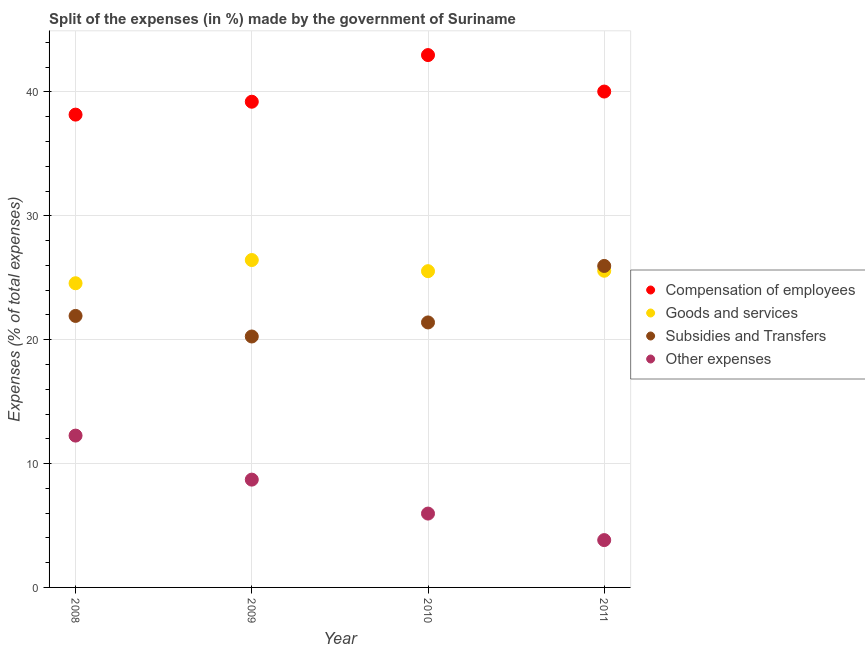How many different coloured dotlines are there?
Ensure brevity in your answer.  4. What is the percentage of amount spent on other expenses in 2011?
Offer a terse response. 3.82. Across all years, what is the maximum percentage of amount spent on subsidies?
Offer a very short reply. 25.95. Across all years, what is the minimum percentage of amount spent on subsidies?
Provide a succinct answer. 20.26. In which year was the percentage of amount spent on other expenses maximum?
Your answer should be very brief. 2008. In which year was the percentage of amount spent on compensation of employees minimum?
Your response must be concise. 2008. What is the total percentage of amount spent on goods and services in the graph?
Keep it short and to the point. 102.08. What is the difference between the percentage of amount spent on goods and services in 2008 and that in 2011?
Provide a succinct answer. -1.01. What is the difference between the percentage of amount spent on goods and services in 2011 and the percentage of amount spent on compensation of employees in 2008?
Provide a short and direct response. -12.6. What is the average percentage of amount spent on goods and services per year?
Offer a terse response. 25.52. In the year 2009, what is the difference between the percentage of amount spent on other expenses and percentage of amount spent on goods and services?
Give a very brief answer. -17.73. In how many years, is the percentage of amount spent on other expenses greater than 18 %?
Your answer should be compact. 0. What is the ratio of the percentage of amount spent on goods and services in 2009 to that in 2011?
Provide a short and direct response. 1.03. Is the percentage of amount spent on other expenses in 2009 less than that in 2010?
Ensure brevity in your answer.  No. Is the difference between the percentage of amount spent on other expenses in 2009 and 2010 greater than the difference between the percentage of amount spent on goods and services in 2009 and 2010?
Give a very brief answer. Yes. What is the difference between the highest and the second highest percentage of amount spent on compensation of employees?
Keep it short and to the point. 2.94. What is the difference between the highest and the lowest percentage of amount spent on goods and services?
Your response must be concise. 1.87. In how many years, is the percentage of amount spent on goods and services greater than the average percentage of amount spent on goods and services taken over all years?
Make the answer very short. 3. Is it the case that in every year, the sum of the percentage of amount spent on subsidies and percentage of amount spent on compensation of employees is greater than the sum of percentage of amount spent on other expenses and percentage of amount spent on goods and services?
Your response must be concise. Yes. Is it the case that in every year, the sum of the percentage of amount spent on compensation of employees and percentage of amount spent on goods and services is greater than the percentage of amount spent on subsidies?
Your answer should be very brief. Yes. Is the percentage of amount spent on subsidies strictly greater than the percentage of amount spent on other expenses over the years?
Make the answer very short. Yes. How many years are there in the graph?
Make the answer very short. 4. What is the difference between two consecutive major ticks on the Y-axis?
Keep it short and to the point. 10. Are the values on the major ticks of Y-axis written in scientific E-notation?
Ensure brevity in your answer.  No. Does the graph contain any zero values?
Provide a succinct answer. No. Does the graph contain grids?
Your answer should be very brief. Yes. How many legend labels are there?
Give a very brief answer. 4. What is the title of the graph?
Offer a terse response. Split of the expenses (in %) made by the government of Suriname. What is the label or title of the Y-axis?
Your answer should be compact. Expenses (% of total expenses). What is the Expenses (% of total expenses) of Compensation of employees in 2008?
Provide a succinct answer. 38.17. What is the Expenses (% of total expenses) in Goods and services in 2008?
Provide a succinct answer. 24.56. What is the Expenses (% of total expenses) of Subsidies and Transfers in 2008?
Provide a short and direct response. 21.92. What is the Expenses (% of total expenses) in Other expenses in 2008?
Your response must be concise. 12.26. What is the Expenses (% of total expenses) of Compensation of employees in 2009?
Offer a very short reply. 39.21. What is the Expenses (% of total expenses) of Goods and services in 2009?
Offer a very short reply. 26.43. What is the Expenses (% of total expenses) of Subsidies and Transfers in 2009?
Your answer should be compact. 20.26. What is the Expenses (% of total expenses) in Other expenses in 2009?
Provide a succinct answer. 8.7. What is the Expenses (% of total expenses) in Compensation of employees in 2010?
Your answer should be very brief. 42.98. What is the Expenses (% of total expenses) in Goods and services in 2010?
Offer a terse response. 25.53. What is the Expenses (% of total expenses) of Subsidies and Transfers in 2010?
Offer a very short reply. 21.39. What is the Expenses (% of total expenses) of Other expenses in 2010?
Keep it short and to the point. 5.96. What is the Expenses (% of total expenses) in Compensation of employees in 2011?
Keep it short and to the point. 40.03. What is the Expenses (% of total expenses) in Goods and services in 2011?
Keep it short and to the point. 25.57. What is the Expenses (% of total expenses) in Subsidies and Transfers in 2011?
Offer a terse response. 25.95. What is the Expenses (% of total expenses) in Other expenses in 2011?
Provide a short and direct response. 3.82. Across all years, what is the maximum Expenses (% of total expenses) in Compensation of employees?
Make the answer very short. 42.98. Across all years, what is the maximum Expenses (% of total expenses) in Goods and services?
Provide a succinct answer. 26.43. Across all years, what is the maximum Expenses (% of total expenses) of Subsidies and Transfers?
Make the answer very short. 25.95. Across all years, what is the maximum Expenses (% of total expenses) in Other expenses?
Your answer should be compact. 12.26. Across all years, what is the minimum Expenses (% of total expenses) in Compensation of employees?
Provide a short and direct response. 38.17. Across all years, what is the minimum Expenses (% of total expenses) of Goods and services?
Your answer should be compact. 24.56. Across all years, what is the minimum Expenses (% of total expenses) of Subsidies and Transfers?
Your answer should be compact. 20.26. Across all years, what is the minimum Expenses (% of total expenses) in Other expenses?
Provide a succinct answer. 3.82. What is the total Expenses (% of total expenses) of Compensation of employees in the graph?
Give a very brief answer. 160.38. What is the total Expenses (% of total expenses) of Goods and services in the graph?
Make the answer very short. 102.08. What is the total Expenses (% of total expenses) in Subsidies and Transfers in the graph?
Keep it short and to the point. 89.52. What is the total Expenses (% of total expenses) in Other expenses in the graph?
Keep it short and to the point. 30.74. What is the difference between the Expenses (% of total expenses) in Compensation of employees in 2008 and that in 2009?
Your response must be concise. -1.04. What is the difference between the Expenses (% of total expenses) of Goods and services in 2008 and that in 2009?
Provide a short and direct response. -1.87. What is the difference between the Expenses (% of total expenses) in Subsidies and Transfers in 2008 and that in 2009?
Provide a short and direct response. 1.66. What is the difference between the Expenses (% of total expenses) of Other expenses in 2008 and that in 2009?
Offer a terse response. 3.55. What is the difference between the Expenses (% of total expenses) in Compensation of employees in 2008 and that in 2010?
Your answer should be very brief. -4.81. What is the difference between the Expenses (% of total expenses) of Goods and services in 2008 and that in 2010?
Provide a succinct answer. -0.97. What is the difference between the Expenses (% of total expenses) of Subsidies and Transfers in 2008 and that in 2010?
Provide a short and direct response. 0.53. What is the difference between the Expenses (% of total expenses) in Other expenses in 2008 and that in 2010?
Your answer should be compact. 6.29. What is the difference between the Expenses (% of total expenses) of Compensation of employees in 2008 and that in 2011?
Your answer should be very brief. -1.86. What is the difference between the Expenses (% of total expenses) in Goods and services in 2008 and that in 2011?
Make the answer very short. -1.01. What is the difference between the Expenses (% of total expenses) of Subsidies and Transfers in 2008 and that in 2011?
Your answer should be very brief. -4.03. What is the difference between the Expenses (% of total expenses) in Other expenses in 2008 and that in 2011?
Offer a very short reply. 8.44. What is the difference between the Expenses (% of total expenses) of Compensation of employees in 2009 and that in 2010?
Offer a very short reply. -3.77. What is the difference between the Expenses (% of total expenses) of Goods and services in 2009 and that in 2010?
Your answer should be very brief. 0.9. What is the difference between the Expenses (% of total expenses) of Subsidies and Transfers in 2009 and that in 2010?
Your answer should be very brief. -1.13. What is the difference between the Expenses (% of total expenses) of Other expenses in 2009 and that in 2010?
Provide a succinct answer. 2.74. What is the difference between the Expenses (% of total expenses) of Compensation of employees in 2009 and that in 2011?
Offer a very short reply. -0.82. What is the difference between the Expenses (% of total expenses) in Goods and services in 2009 and that in 2011?
Provide a short and direct response. 0.86. What is the difference between the Expenses (% of total expenses) in Subsidies and Transfers in 2009 and that in 2011?
Give a very brief answer. -5.69. What is the difference between the Expenses (% of total expenses) in Other expenses in 2009 and that in 2011?
Offer a very short reply. 4.88. What is the difference between the Expenses (% of total expenses) in Compensation of employees in 2010 and that in 2011?
Offer a terse response. 2.94. What is the difference between the Expenses (% of total expenses) of Goods and services in 2010 and that in 2011?
Your answer should be compact. -0.03. What is the difference between the Expenses (% of total expenses) in Subsidies and Transfers in 2010 and that in 2011?
Give a very brief answer. -4.56. What is the difference between the Expenses (% of total expenses) in Other expenses in 2010 and that in 2011?
Keep it short and to the point. 2.14. What is the difference between the Expenses (% of total expenses) in Compensation of employees in 2008 and the Expenses (% of total expenses) in Goods and services in 2009?
Make the answer very short. 11.74. What is the difference between the Expenses (% of total expenses) of Compensation of employees in 2008 and the Expenses (% of total expenses) of Subsidies and Transfers in 2009?
Ensure brevity in your answer.  17.91. What is the difference between the Expenses (% of total expenses) of Compensation of employees in 2008 and the Expenses (% of total expenses) of Other expenses in 2009?
Keep it short and to the point. 29.47. What is the difference between the Expenses (% of total expenses) of Goods and services in 2008 and the Expenses (% of total expenses) of Subsidies and Transfers in 2009?
Your answer should be very brief. 4.3. What is the difference between the Expenses (% of total expenses) in Goods and services in 2008 and the Expenses (% of total expenses) in Other expenses in 2009?
Offer a terse response. 15.85. What is the difference between the Expenses (% of total expenses) in Subsidies and Transfers in 2008 and the Expenses (% of total expenses) in Other expenses in 2009?
Provide a succinct answer. 13.22. What is the difference between the Expenses (% of total expenses) of Compensation of employees in 2008 and the Expenses (% of total expenses) of Goods and services in 2010?
Make the answer very short. 12.64. What is the difference between the Expenses (% of total expenses) in Compensation of employees in 2008 and the Expenses (% of total expenses) in Subsidies and Transfers in 2010?
Make the answer very short. 16.78. What is the difference between the Expenses (% of total expenses) of Compensation of employees in 2008 and the Expenses (% of total expenses) of Other expenses in 2010?
Make the answer very short. 32.21. What is the difference between the Expenses (% of total expenses) of Goods and services in 2008 and the Expenses (% of total expenses) of Subsidies and Transfers in 2010?
Give a very brief answer. 3.16. What is the difference between the Expenses (% of total expenses) of Goods and services in 2008 and the Expenses (% of total expenses) of Other expenses in 2010?
Ensure brevity in your answer.  18.59. What is the difference between the Expenses (% of total expenses) of Subsidies and Transfers in 2008 and the Expenses (% of total expenses) of Other expenses in 2010?
Your response must be concise. 15.96. What is the difference between the Expenses (% of total expenses) of Compensation of employees in 2008 and the Expenses (% of total expenses) of Goods and services in 2011?
Keep it short and to the point. 12.6. What is the difference between the Expenses (% of total expenses) in Compensation of employees in 2008 and the Expenses (% of total expenses) in Subsidies and Transfers in 2011?
Give a very brief answer. 12.22. What is the difference between the Expenses (% of total expenses) of Compensation of employees in 2008 and the Expenses (% of total expenses) of Other expenses in 2011?
Ensure brevity in your answer.  34.35. What is the difference between the Expenses (% of total expenses) in Goods and services in 2008 and the Expenses (% of total expenses) in Subsidies and Transfers in 2011?
Provide a succinct answer. -1.4. What is the difference between the Expenses (% of total expenses) in Goods and services in 2008 and the Expenses (% of total expenses) in Other expenses in 2011?
Provide a succinct answer. 20.73. What is the difference between the Expenses (% of total expenses) of Subsidies and Transfers in 2008 and the Expenses (% of total expenses) of Other expenses in 2011?
Give a very brief answer. 18.1. What is the difference between the Expenses (% of total expenses) of Compensation of employees in 2009 and the Expenses (% of total expenses) of Goods and services in 2010?
Offer a very short reply. 13.68. What is the difference between the Expenses (% of total expenses) of Compensation of employees in 2009 and the Expenses (% of total expenses) of Subsidies and Transfers in 2010?
Offer a very short reply. 17.82. What is the difference between the Expenses (% of total expenses) in Compensation of employees in 2009 and the Expenses (% of total expenses) in Other expenses in 2010?
Your answer should be compact. 33.25. What is the difference between the Expenses (% of total expenses) in Goods and services in 2009 and the Expenses (% of total expenses) in Subsidies and Transfers in 2010?
Keep it short and to the point. 5.04. What is the difference between the Expenses (% of total expenses) in Goods and services in 2009 and the Expenses (% of total expenses) in Other expenses in 2010?
Your answer should be compact. 20.47. What is the difference between the Expenses (% of total expenses) in Subsidies and Transfers in 2009 and the Expenses (% of total expenses) in Other expenses in 2010?
Your answer should be very brief. 14.3. What is the difference between the Expenses (% of total expenses) of Compensation of employees in 2009 and the Expenses (% of total expenses) of Goods and services in 2011?
Offer a very short reply. 13.64. What is the difference between the Expenses (% of total expenses) in Compensation of employees in 2009 and the Expenses (% of total expenses) in Subsidies and Transfers in 2011?
Offer a terse response. 13.26. What is the difference between the Expenses (% of total expenses) in Compensation of employees in 2009 and the Expenses (% of total expenses) in Other expenses in 2011?
Provide a succinct answer. 35.39. What is the difference between the Expenses (% of total expenses) of Goods and services in 2009 and the Expenses (% of total expenses) of Subsidies and Transfers in 2011?
Your answer should be compact. 0.48. What is the difference between the Expenses (% of total expenses) in Goods and services in 2009 and the Expenses (% of total expenses) in Other expenses in 2011?
Provide a succinct answer. 22.61. What is the difference between the Expenses (% of total expenses) in Subsidies and Transfers in 2009 and the Expenses (% of total expenses) in Other expenses in 2011?
Provide a succinct answer. 16.44. What is the difference between the Expenses (% of total expenses) in Compensation of employees in 2010 and the Expenses (% of total expenses) in Goods and services in 2011?
Make the answer very short. 17.41. What is the difference between the Expenses (% of total expenses) of Compensation of employees in 2010 and the Expenses (% of total expenses) of Subsidies and Transfers in 2011?
Your response must be concise. 17.02. What is the difference between the Expenses (% of total expenses) in Compensation of employees in 2010 and the Expenses (% of total expenses) in Other expenses in 2011?
Your response must be concise. 39.15. What is the difference between the Expenses (% of total expenses) of Goods and services in 2010 and the Expenses (% of total expenses) of Subsidies and Transfers in 2011?
Ensure brevity in your answer.  -0.42. What is the difference between the Expenses (% of total expenses) in Goods and services in 2010 and the Expenses (% of total expenses) in Other expenses in 2011?
Provide a short and direct response. 21.71. What is the difference between the Expenses (% of total expenses) of Subsidies and Transfers in 2010 and the Expenses (% of total expenses) of Other expenses in 2011?
Provide a short and direct response. 17.57. What is the average Expenses (% of total expenses) of Compensation of employees per year?
Offer a very short reply. 40.1. What is the average Expenses (% of total expenses) of Goods and services per year?
Give a very brief answer. 25.52. What is the average Expenses (% of total expenses) in Subsidies and Transfers per year?
Offer a very short reply. 22.38. What is the average Expenses (% of total expenses) of Other expenses per year?
Offer a terse response. 7.69. In the year 2008, what is the difference between the Expenses (% of total expenses) of Compensation of employees and Expenses (% of total expenses) of Goods and services?
Offer a terse response. 13.61. In the year 2008, what is the difference between the Expenses (% of total expenses) in Compensation of employees and Expenses (% of total expenses) in Subsidies and Transfers?
Your response must be concise. 16.25. In the year 2008, what is the difference between the Expenses (% of total expenses) in Compensation of employees and Expenses (% of total expenses) in Other expenses?
Provide a short and direct response. 25.91. In the year 2008, what is the difference between the Expenses (% of total expenses) in Goods and services and Expenses (% of total expenses) in Subsidies and Transfers?
Provide a short and direct response. 2.64. In the year 2008, what is the difference between the Expenses (% of total expenses) of Goods and services and Expenses (% of total expenses) of Other expenses?
Offer a terse response. 12.3. In the year 2008, what is the difference between the Expenses (% of total expenses) of Subsidies and Transfers and Expenses (% of total expenses) of Other expenses?
Give a very brief answer. 9.66. In the year 2009, what is the difference between the Expenses (% of total expenses) of Compensation of employees and Expenses (% of total expenses) of Goods and services?
Provide a short and direct response. 12.78. In the year 2009, what is the difference between the Expenses (% of total expenses) in Compensation of employees and Expenses (% of total expenses) in Subsidies and Transfers?
Your response must be concise. 18.95. In the year 2009, what is the difference between the Expenses (% of total expenses) in Compensation of employees and Expenses (% of total expenses) in Other expenses?
Offer a terse response. 30.51. In the year 2009, what is the difference between the Expenses (% of total expenses) in Goods and services and Expenses (% of total expenses) in Subsidies and Transfers?
Offer a very short reply. 6.17. In the year 2009, what is the difference between the Expenses (% of total expenses) of Goods and services and Expenses (% of total expenses) of Other expenses?
Keep it short and to the point. 17.73. In the year 2009, what is the difference between the Expenses (% of total expenses) of Subsidies and Transfers and Expenses (% of total expenses) of Other expenses?
Keep it short and to the point. 11.55. In the year 2010, what is the difference between the Expenses (% of total expenses) in Compensation of employees and Expenses (% of total expenses) in Goods and services?
Ensure brevity in your answer.  17.45. In the year 2010, what is the difference between the Expenses (% of total expenses) of Compensation of employees and Expenses (% of total expenses) of Subsidies and Transfers?
Offer a very short reply. 21.58. In the year 2010, what is the difference between the Expenses (% of total expenses) in Compensation of employees and Expenses (% of total expenses) in Other expenses?
Your answer should be very brief. 37.01. In the year 2010, what is the difference between the Expenses (% of total expenses) in Goods and services and Expenses (% of total expenses) in Subsidies and Transfers?
Offer a very short reply. 4.14. In the year 2010, what is the difference between the Expenses (% of total expenses) in Goods and services and Expenses (% of total expenses) in Other expenses?
Make the answer very short. 19.57. In the year 2010, what is the difference between the Expenses (% of total expenses) in Subsidies and Transfers and Expenses (% of total expenses) in Other expenses?
Keep it short and to the point. 15.43. In the year 2011, what is the difference between the Expenses (% of total expenses) of Compensation of employees and Expenses (% of total expenses) of Goods and services?
Your answer should be very brief. 14.47. In the year 2011, what is the difference between the Expenses (% of total expenses) in Compensation of employees and Expenses (% of total expenses) in Subsidies and Transfers?
Make the answer very short. 14.08. In the year 2011, what is the difference between the Expenses (% of total expenses) in Compensation of employees and Expenses (% of total expenses) in Other expenses?
Keep it short and to the point. 36.21. In the year 2011, what is the difference between the Expenses (% of total expenses) of Goods and services and Expenses (% of total expenses) of Subsidies and Transfers?
Ensure brevity in your answer.  -0.39. In the year 2011, what is the difference between the Expenses (% of total expenses) in Goods and services and Expenses (% of total expenses) in Other expenses?
Offer a very short reply. 21.74. In the year 2011, what is the difference between the Expenses (% of total expenses) in Subsidies and Transfers and Expenses (% of total expenses) in Other expenses?
Your answer should be very brief. 22.13. What is the ratio of the Expenses (% of total expenses) of Compensation of employees in 2008 to that in 2009?
Keep it short and to the point. 0.97. What is the ratio of the Expenses (% of total expenses) of Goods and services in 2008 to that in 2009?
Your response must be concise. 0.93. What is the ratio of the Expenses (% of total expenses) in Subsidies and Transfers in 2008 to that in 2009?
Keep it short and to the point. 1.08. What is the ratio of the Expenses (% of total expenses) in Other expenses in 2008 to that in 2009?
Your response must be concise. 1.41. What is the ratio of the Expenses (% of total expenses) of Compensation of employees in 2008 to that in 2010?
Keep it short and to the point. 0.89. What is the ratio of the Expenses (% of total expenses) in Goods and services in 2008 to that in 2010?
Give a very brief answer. 0.96. What is the ratio of the Expenses (% of total expenses) of Subsidies and Transfers in 2008 to that in 2010?
Provide a succinct answer. 1.02. What is the ratio of the Expenses (% of total expenses) of Other expenses in 2008 to that in 2010?
Your answer should be very brief. 2.06. What is the ratio of the Expenses (% of total expenses) of Compensation of employees in 2008 to that in 2011?
Your answer should be very brief. 0.95. What is the ratio of the Expenses (% of total expenses) in Goods and services in 2008 to that in 2011?
Make the answer very short. 0.96. What is the ratio of the Expenses (% of total expenses) of Subsidies and Transfers in 2008 to that in 2011?
Keep it short and to the point. 0.84. What is the ratio of the Expenses (% of total expenses) in Other expenses in 2008 to that in 2011?
Your response must be concise. 3.21. What is the ratio of the Expenses (% of total expenses) in Compensation of employees in 2009 to that in 2010?
Keep it short and to the point. 0.91. What is the ratio of the Expenses (% of total expenses) of Goods and services in 2009 to that in 2010?
Your response must be concise. 1.04. What is the ratio of the Expenses (% of total expenses) of Subsidies and Transfers in 2009 to that in 2010?
Provide a short and direct response. 0.95. What is the ratio of the Expenses (% of total expenses) in Other expenses in 2009 to that in 2010?
Provide a succinct answer. 1.46. What is the ratio of the Expenses (% of total expenses) in Compensation of employees in 2009 to that in 2011?
Ensure brevity in your answer.  0.98. What is the ratio of the Expenses (% of total expenses) of Goods and services in 2009 to that in 2011?
Give a very brief answer. 1.03. What is the ratio of the Expenses (% of total expenses) of Subsidies and Transfers in 2009 to that in 2011?
Give a very brief answer. 0.78. What is the ratio of the Expenses (% of total expenses) of Other expenses in 2009 to that in 2011?
Provide a short and direct response. 2.28. What is the ratio of the Expenses (% of total expenses) in Compensation of employees in 2010 to that in 2011?
Offer a very short reply. 1.07. What is the ratio of the Expenses (% of total expenses) in Subsidies and Transfers in 2010 to that in 2011?
Offer a very short reply. 0.82. What is the ratio of the Expenses (% of total expenses) in Other expenses in 2010 to that in 2011?
Ensure brevity in your answer.  1.56. What is the difference between the highest and the second highest Expenses (% of total expenses) in Compensation of employees?
Your answer should be very brief. 2.94. What is the difference between the highest and the second highest Expenses (% of total expenses) of Goods and services?
Make the answer very short. 0.86. What is the difference between the highest and the second highest Expenses (% of total expenses) in Subsidies and Transfers?
Offer a terse response. 4.03. What is the difference between the highest and the second highest Expenses (% of total expenses) of Other expenses?
Your answer should be compact. 3.55. What is the difference between the highest and the lowest Expenses (% of total expenses) of Compensation of employees?
Offer a terse response. 4.81. What is the difference between the highest and the lowest Expenses (% of total expenses) in Goods and services?
Offer a terse response. 1.87. What is the difference between the highest and the lowest Expenses (% of total expenses) in Subsidies and Transfers?
Offer a very short reply. 5.69. What is the difference between the highest and the lowest Expenses (% of total expenses) in Other expenses?
Provide a succinct answer. 8.44. 